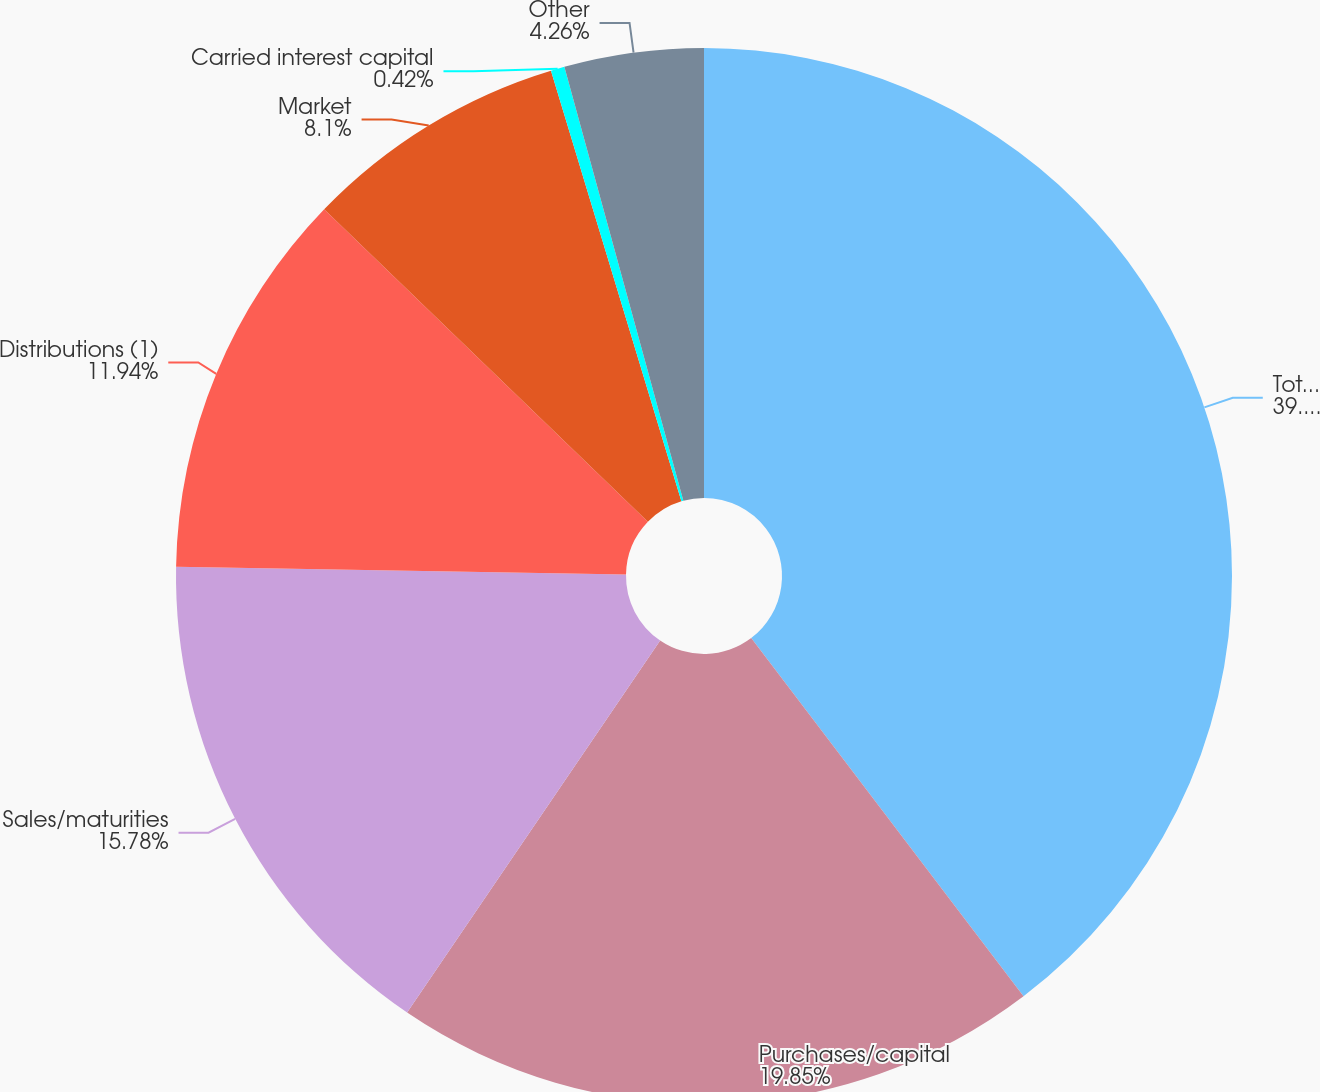<chart> <loc_0><loc_0><loc_500><loc_500><pie_chart><fcel>Total Investments as adjusted<fcel>Purchases/capital<fcel>Sales/maturities<fcel>Distributions (1)<fcel>Market<fcel>Carried interest capital<fcel>Other<nl><fcel>39.66%<fcel>19.85%<fcel>15.78%<fcel>11.94%<fcel>8.1%<fcel>0.42%<fcel>4.26%<nl></chart> 